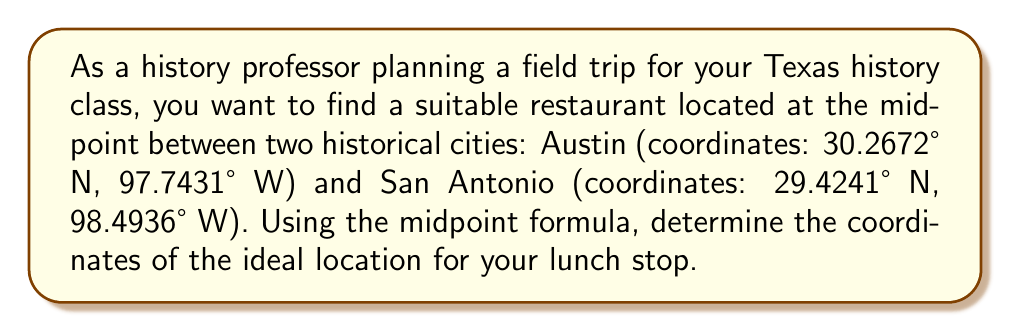Solve this math problem. To solve this problem, we'll use the midpoint formula in two dimensions. The midpoint formula is:

$$ \text{Midpoint} = \left(\frac{x_1 + x_2}{2}, \frac{y_1 + y_2}{2}\right) $$

Where $(x_1, y_1)$ are the coordinates of the first point and $(x_2, y_2)$ are the coordinates of the second point.

In this case, we'll use latitude for $y$ and longitude for $x$. Note that we need to be careful with the negative sign for longitude, as locations in the Western Hemisphere have negative longitude values.

Austin: (30.2672° N, 97.7431° W) = $(x_1, y_1) = (-97.7431, 30.2672)$
San Antonio: (29.4241° N, 98.4936° W) = $(x_2, y_2) = (-98.4936, 29.4241)$

Now, let's apply the midpoint formula:

For longitude (x-coordinate):
$$ x_{\text{midpoint}} = \frac{x_1 + x_2}{2} = \frac{-97.7431 + (-98.4936)}{2} = \frac{-196.2367}{2} = -98.11835 $$

For latitude (y-coordinate):
$$ y_{\text{midpoint}} = \frac{y_1 + y_2}{2} = \frac{30.2672 + 29.4241}{2} = \frac{59.6913}{2} = 29.84565 $$

Therefore, the midpoint coordinates are (-98.11835° W, 29.84565° N).
Answer: The ideal location for the lunch stop is at coordinates 29.84565° N, 98.11835° W. 